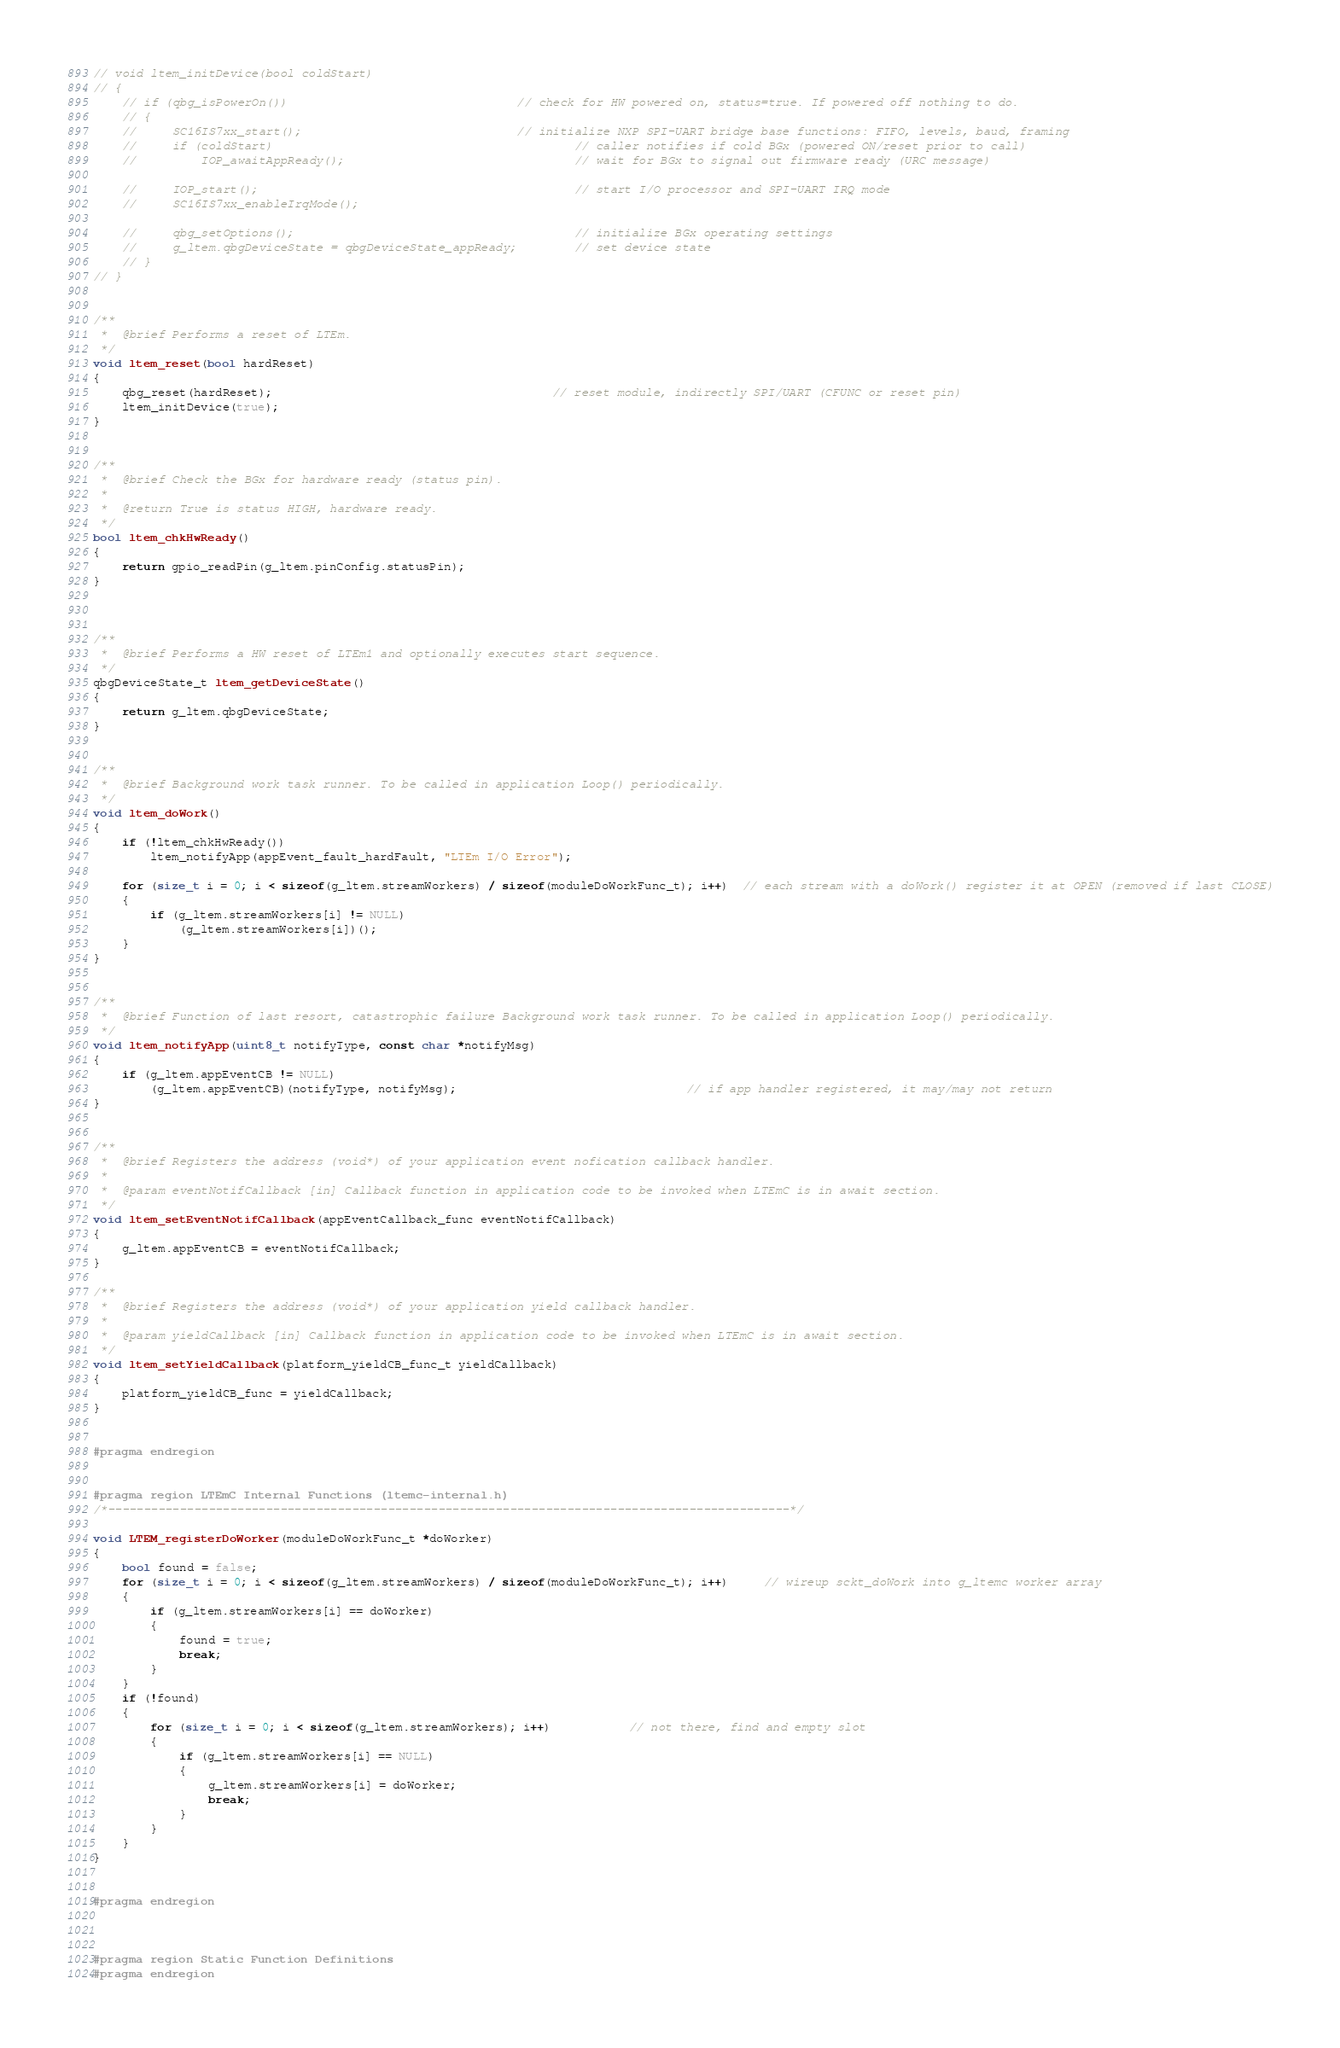Convert code to text. <code><loc_0><loc_0><loc_500><loc_500><_C_>// void ltem_initDevice(bool coldStart)
// {
    // if (qbg_isPowerOn())                                // check for HW powered on, status=true. If powered off nothing to do.
    // {
    //     SC16IS7xx_start();                              // initialize NXP SPI-UART bridge base functions: FIFO, levels, baud, framing
    //     if (coldStart)                                          // caller notifies if cold BGx (powered ON/reset prior to call)
    //         IOP_awaitAppReady();                                // wait for BGx to signal out firmware ready (URC message)

    //     IOP_start();                                            // start I/O processor and SPI-UART IRQ mode
    //     SC16IS7xx_enableIrqMode();

    //     qbg_setOptions();                                       // initialize BGx operating settings
    //     g_ltem.qbgDeviceState = qbgDeviceState_appReady;        // set device state
    // }
// }


/**
 *	@brief Performs a reset of LTEm.
 */
void ltem_reset(bool hardReset)
{
    qbg_reset(hardReset);                                       // reset module, indirectly SPI/UART (CFUNC or reset pin)
    ltem_initDevice(true);
}


/**
 *	@brief Check the BGx for hardware ready (status pin).
 *
 *  @return True is status HIGH, hardware ready.
 */
bool ltem_chkHwReady()
{
	return gpio_readPin(g_ltem.pinConfig.statusPin);
}



/**
 *	@brief Performs a HW reset of LTEm1 and optionally executes start sequence.
 */
qbgDeviceState_t ltem_getDeviceState()
{
    return g_ltem.qbgDeviceState;
}


/**
 *	@brief Background work task runner. To be called in application Loop() periodically.
 */
void ltem_doWork()
{
    if (!ltem_chkHwReady())
        ltem_notifyApp(appEvent_fault_hardFault, "LTEm I/O Error");

    for (size_t i = 0; i < sizeof(g_ltem.streamWorkers) / sizeof(moduleDoWorkFunc_t); i++)  // each stream with a doWork() register it at OPEN (removed if last CLOSE)
    {
        if (g_ltem.streamWorkers[i] != NULL)
            (g_ltem.streamWorkers[i])();
    }
}


/**
 *	@brief Function of last resort, catastrophic failure Background work task runner. To be called in application Loop() periodically.
 */
void ltem_notifyApp(uint8_t notifyType, const char *notifyMsg)
{
    if (g_ltem.appEventCB != NULL)                                       
        (g_ltem.appEventCB)(notifyType, notifyMsg);                                // if app handler registered, it may/may not return
}


/**
 *	@brief Registers the address (void*) of your application event nofication callback handler.
 * 
 *  @param eventNotifCallback [in] Callback function in application code to be invoked when LTEmC is in await section.
 */
void ltem_setEventNotifCallback(appEventCallback_func eventNotifCallback)
{
    g_ltem.appEventCB = eventNotifCallback;
}

/**
 *	@brief Registers the address (void*) of your application yield callback handler.
 * 
 *  @param yieldCallback [in] Callback function in application code to be invoked when LTEmC is in await section.
 */
void ltem_setYieldCallback(platform_yieldCB_func_t yieldCallback)
{
    platform_yieldCB_func = yieldCallback;
}


#pragma endregion


#pragma region LTEmC Internal Functions (ltemc-internal.h)
/*-----------------------------------------------------------------------------------------------*/

void LTEM_registerDoWorker(moduleDoWorkFunc_t *doWorker)
{
    bool found = false;
    for (size_t i = 0; i < sizeof(g_ltem.streamWorkers) / sizeof(moduleDoWorkFunc_t); i++)     // wireup sckt_doWork into g_ltemc worker array
    {
        if (g_ltem.streamWorkers[i] == doWorker)
        {
            found = true;
            break;
        }
    }
    if (!found)
    {
        for (size_t i = 0; i < sizeof(g_ltem.streamWorkers); i++)           // not there, find and empty slot
        {
            if (g_ltem.streamWorkers[i] == NULL)
            {
                g_ltem.streamWorkers[i] = doWorker;
                break;
            }
        }
    }
}


#pragma endregion



#pragma region Static Function Definitions
#pragma endregion
</code> 